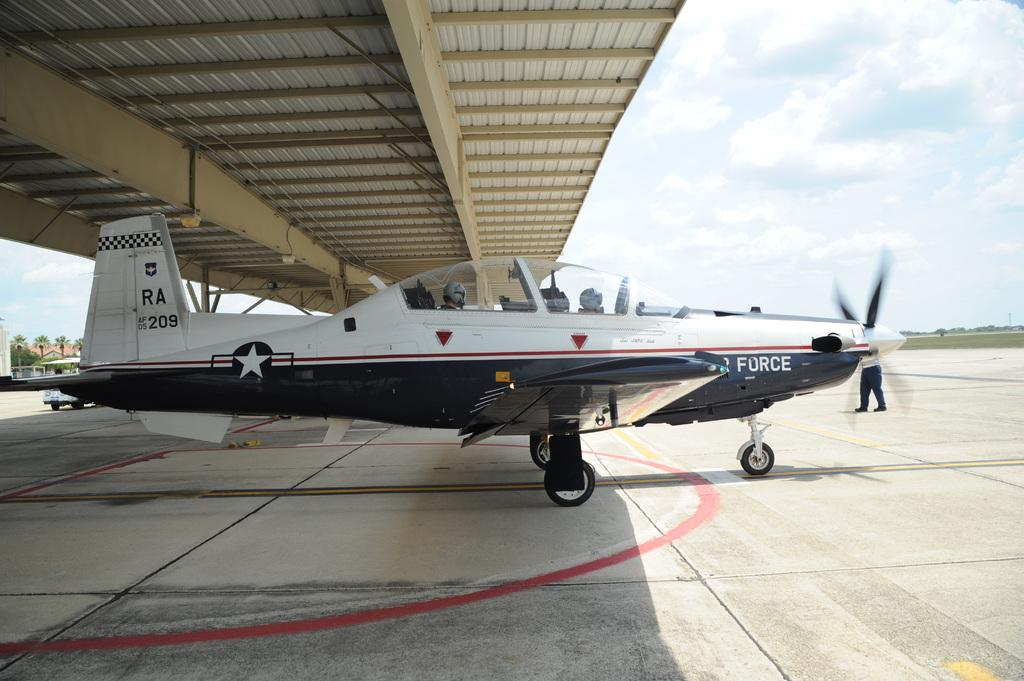Provide a one-sentence caption for the provided image. Airplane from air force about to fly from off the ground. 